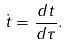<formula> <loc_0><loc_0><loc_500><loc_500>\dot { t } = \frac { d t } { d \tau } .</formula> 